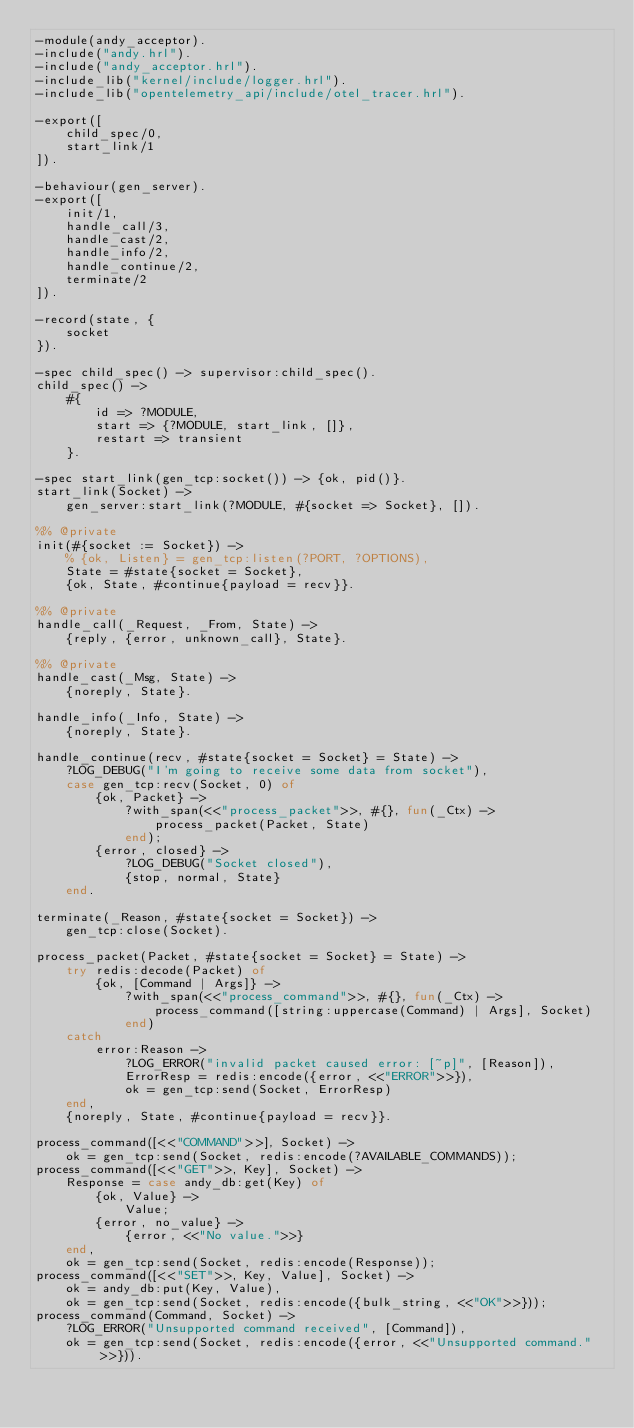Convert code to text. <code><loc_0><loc_0><loc_500><loc_500><_Erlang_>-module(andy_acceptor).
-include("andy.hrl").
-include("andy_acceptor.hrl").
-include_lib("kernel/include/logger.hrl").
-include_lib("opentelemetry_api/include/otel_tracer.hrl").

-export([
    child_spec/0,
    start_link/1
]).

-behaviour(gen_server).
-export([
    init/1,
    handle_call/3,
    handle_cast/2,
    handle_info/2,
    handle_continue/2,
    terminate/2
]).

-record(state, {
    socket
}).

-spec child_spec() -> supervisor:child_spec().
child_spec() ->
    #{
        id => ?MODULE,
        start => {?MODULE, start_link, []},
        restart => transient
    }.

-spec start_link(gen_tcp:socket()) -> {ok, pid()}.
start_link(Socket) ->
    gen_server:start_link(?MODULE, #{socket => Socket}, []).

%% @private
init(#{socket := Socket}) ->
    % {ok, Listen} = gen_tcp:listen(?PORT, ?OPTIONS),
    State = #state{socket = Socket},
    {ok, State, #continue{payload = recv}}.

%% @private
handle_call(_Request, _From, State) ->
    {reply, {error, unknown_call}, State}.

%% @private
handle_cast(_Msg, State) ->
    {noreply, State}.

handle_info(_Info, State) ->
    {noreply, State}.

handle_continue(recv, #state{socket = Socket} = State) ->
    ?LOG_DEBUG("I'm going to receive some data from socket"),
    case gen_tcp:recv(Socket, 0) of
        {ok, Packet} ->
            ?with_span(<<"process_packet">>, #{}, fun(_Ctx) ->
                process_packet(Packet, State)
            end);
        {error, closed} ->
            ?LOG_DEBUG("Socket closed"),
            {stop, normal, State}
    end.

terminate(_Reason, #state{socket = Socket}) ->
    gen_tcp:close(Socket).

process_packet(Packet, #state{socket = Socket} = State) ->
    try redis:decode(Packet) of
        {ok, [Command | Args]} ->
            ?with_span(<<"process_command">>, #{}, fun(_Ctx) ->
                process_command([string:uppercase(Command) | Args], Socket)
            end)
    catch
        error:Reason ->
            ?LOG_ERROR("invalid packet caused error: [~p]", [Reason]),
            ErrorResp = redis:encode({error, <<"ERROR">>}),
            ok = gen_tcp:send(Socket, ErrorResp)
    end,
    {noreply, State, #continue{payload = recv}}.

process_command([<<"COMMAND">>], Socket) ->
    ok = gen_tcp:send(Socket, redis:encode(?AVAILABLE_COMMANDS));
process_command([<<"GET">>, Key], Socket) ->
    Response = case andy_db:get(Key) of
        {ok, Value} ->
            Value;
        {error, no_value} ->
            {error, <<"No value.">>}
    end,
    ok = gen_tcp:send(Socket, redis:encode(Response));
process_command([<<"SET">>, Key, Value], Socket) ->
    ok = andy_db:put(Key, Value),
    ok = gen_tcp:send(Socket, redis:encode({bulk_string, <<"OK">>}));
process_command(Command, Socket) ->
    ?LOG_ERROR("Unsupported command received", [Command]),
    ok = gen_tcp:send(Socket, redis:encode({error, <<"Unsupported command.">>})).
</code> 